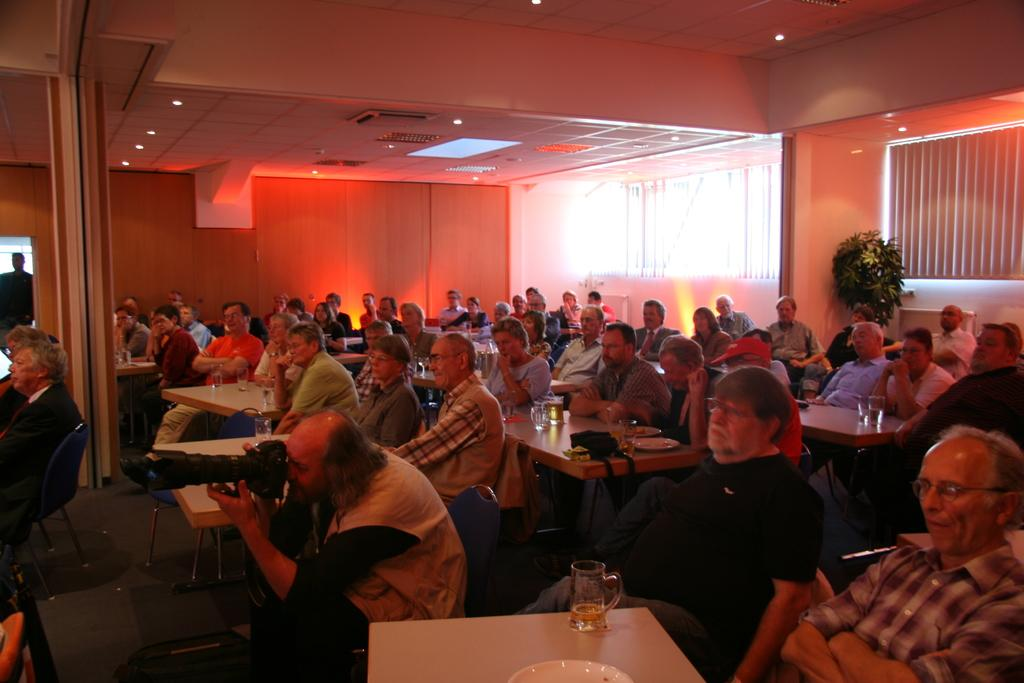What are the people in the image doing? There is a group of people sitting in the image. What can be seen behind the group of people? There is a plant behind the group of people. What is in front of the group of people? There is a table in front of the group of people. What objects are on the table? Wine glasses are present on the table. Can you see a circle of people around a basket in the image? There is no circle of people around a basket in the image; it features a group of people sitting with a plant behind them and a table in front of them. 